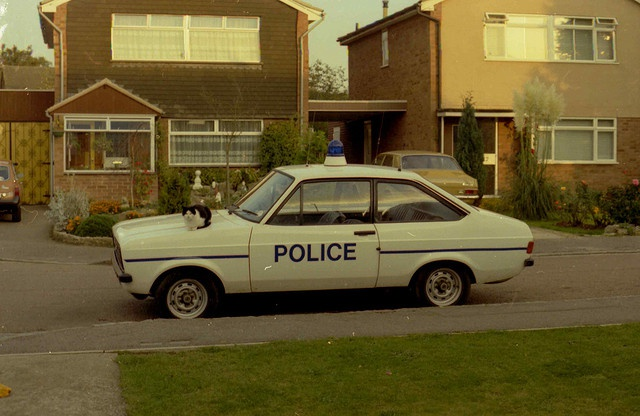Describe the objects in this image and their specific colors. I can see car in beige, tan, black, olive, and gray tones, car in beige, gray, and olive tones, car in beige, black, olive, and gray tones, and cat in beige, black, and olive tones in this image. 